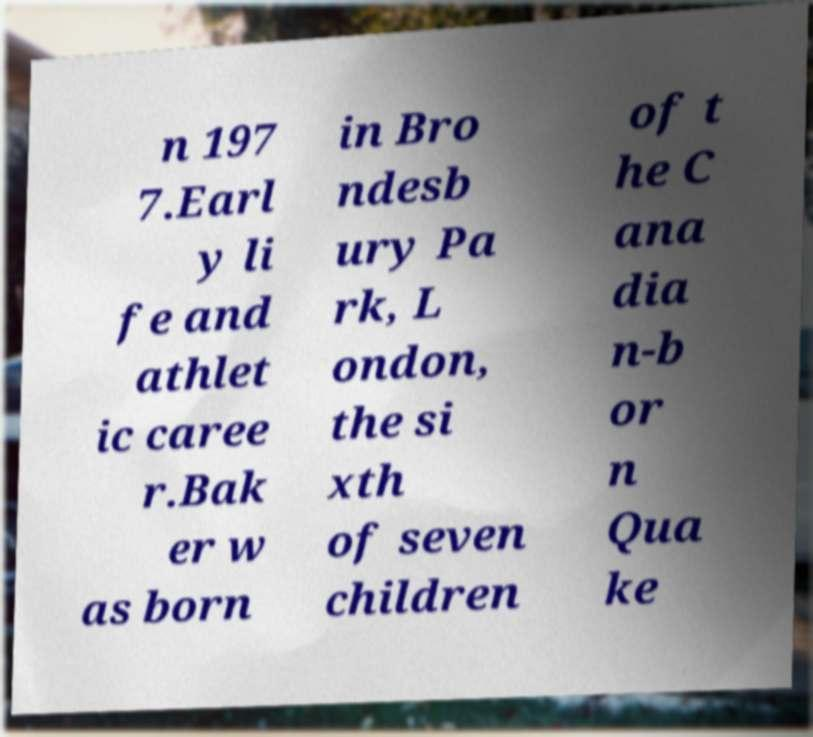For documentation purposes, I need the text within this image transcribed. Could you provide that? n 197 7.Earl y li fe and athlet ic caree r.Bak er w as born in Bro ndesb ury Pa rk, L ondon, the si xth of seven children of t he C ana dia n-b or n Qua ke 